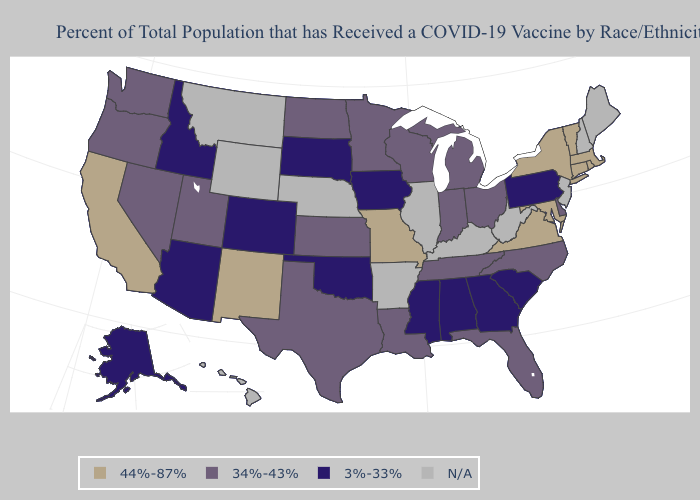Name the states that have a value in the range 3%-33%?
Concise answer only. Alabama, Alaska, Arizona, Colorado, Georgia, Idaho, Iowa, Mississippi, Oklahoma, Pennsylvania, South Carolina, South Dakota. Among the states that border Colorado , does New Mexico have the lowest value?
Concise answer only. No. Name the states that have a value in the range N/A?
Be succinct. Arkansas, Hawaii, Illinois, Kentucky, Maine, Montana, Nebraska, New Hampshire, New Jersey, West Virginia, Wyoming. Does Pennsylvania have the highest value in the Northeast?
Concise answer only. No. Name the states that have a value in the range 3%-33%?
Concise answer only. Alabama, Alaska, Arizona, Colorado, Georgia, Idaho, Iowa, Mississippi, Oklahoma, Pennsylvania, South Carolina, South Dakota. What is the lowest value in states that border Idaho?
Answer briefly. 34%-43%. What is the lowest value in the USA?
Keep it brief. 3%-33%. What is the value of Florida?
Concise answer only. 34%-43%. Name the states that have a value in the range 44%-87%?
Quick response, please. California, Connecticut, Maryland, Massachusetts, Missouri, New Mexico, New York, Rhode Island, Vermont, Virginia. Which states have the highest value in the USA?
Give a very brief answer. California, Connecticut, Maryland, Massachusetts, Missouri, New Mexico, New York, Rhode Island, Vermont, Virginia. What is the highest value in states that border California?
Answer briefly. 34%-43%. Among the states that border Arizona , does New Mexico have the highest value?
Answer briefly. Yes. What is the value of Washington?
Concise answer only. 34%-43%. What is the value of Illinois?
Concise answer only. N/A. 